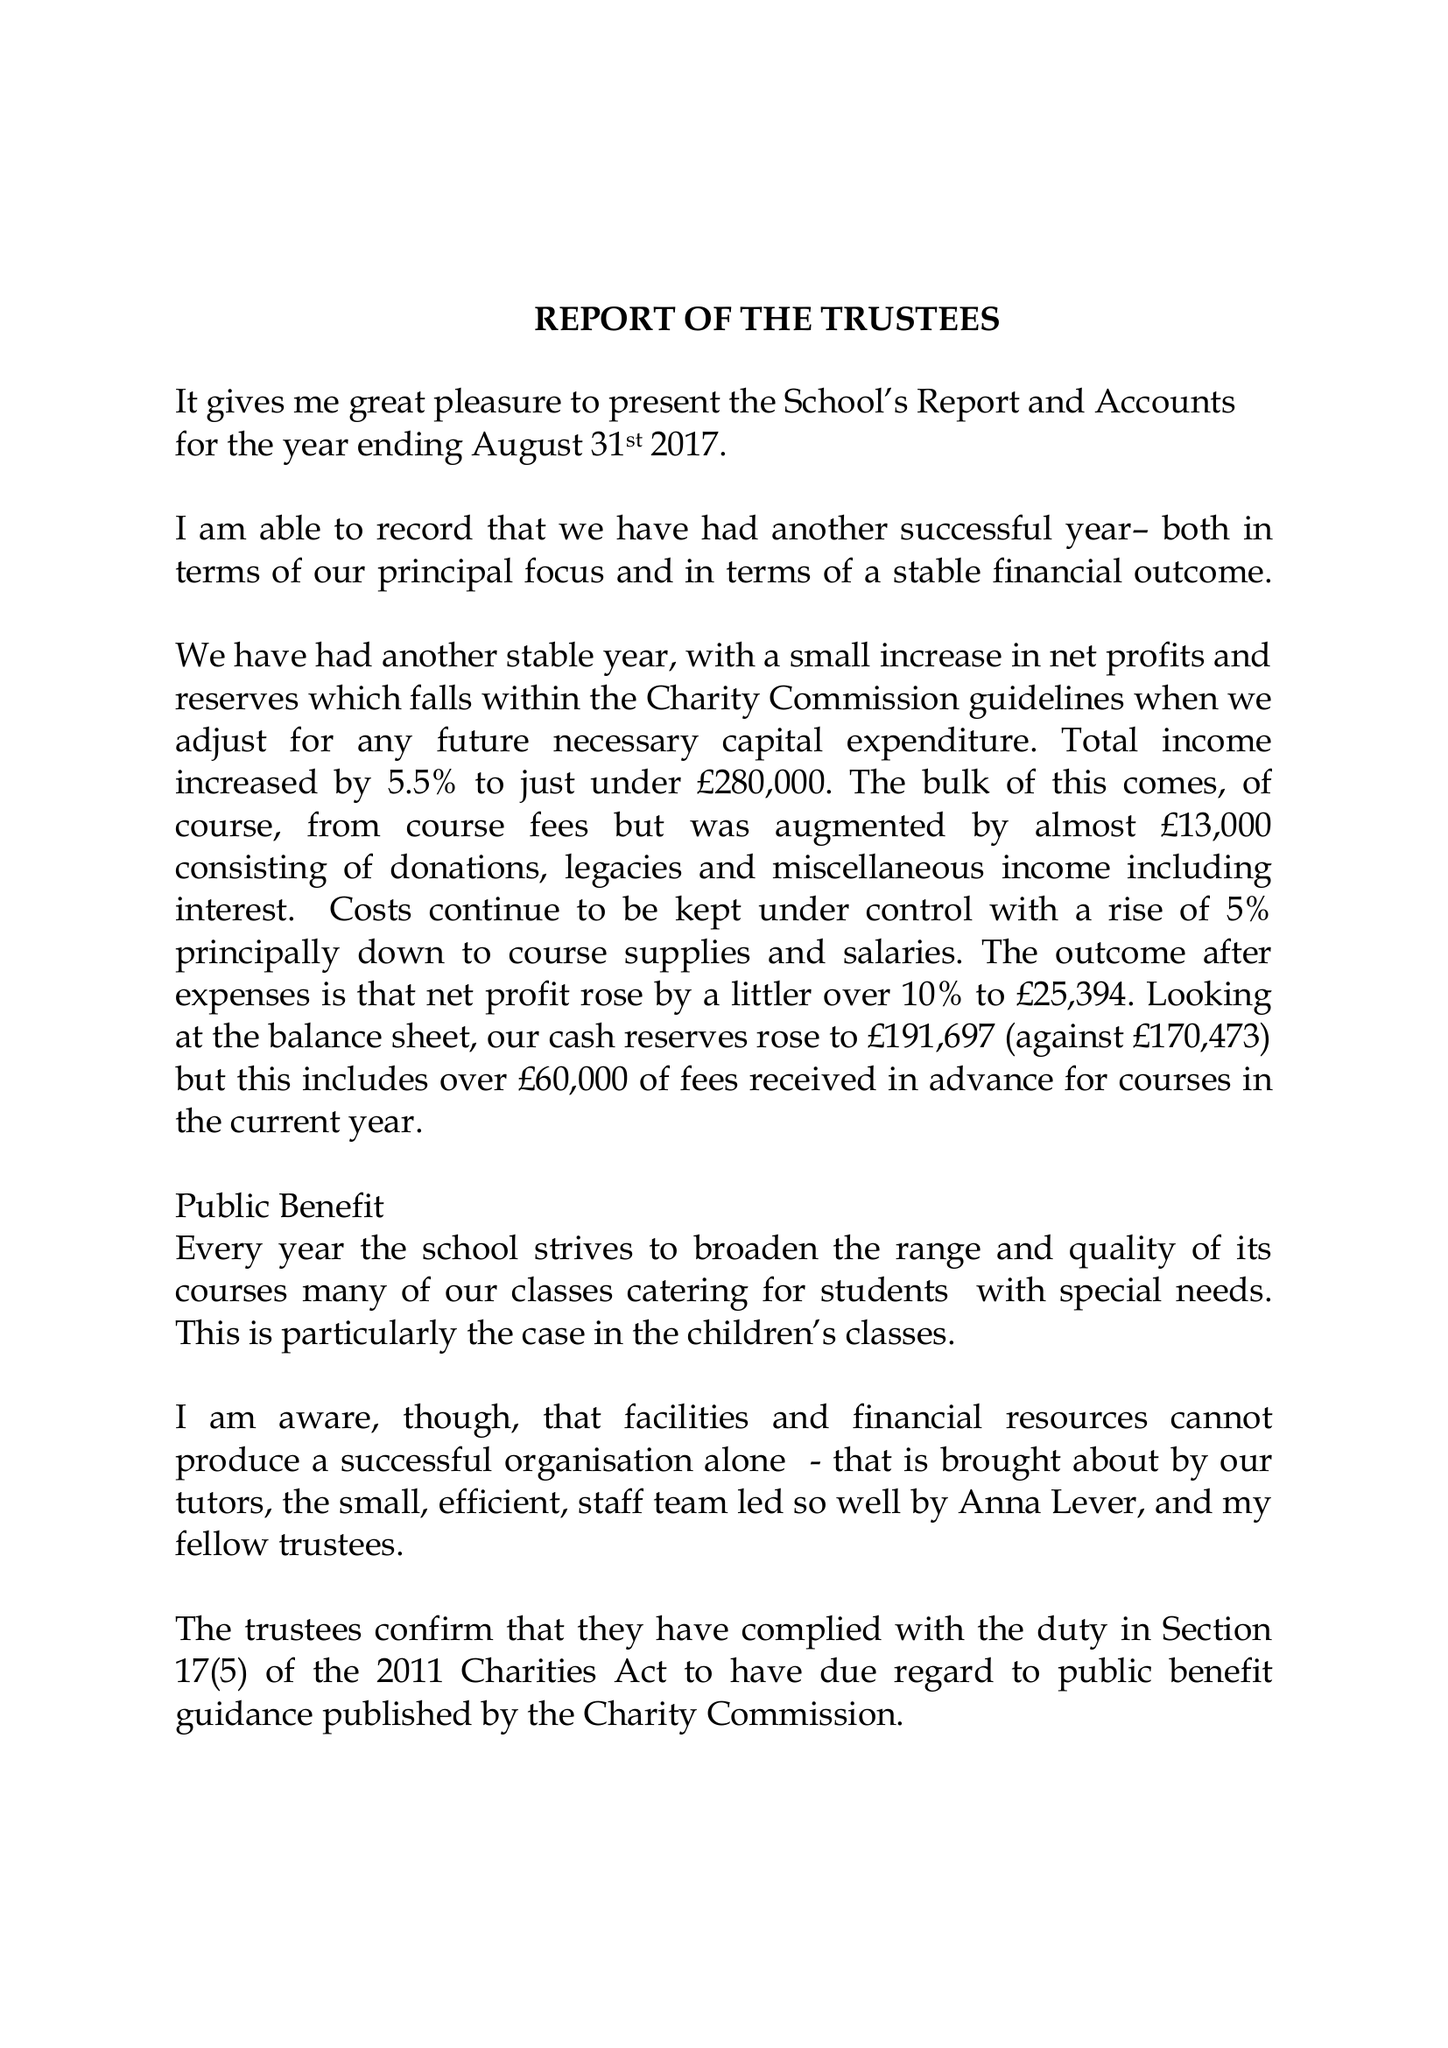What is the value for the address__postcode?
Answer the question using a single word or phrase. OX13 6RD 